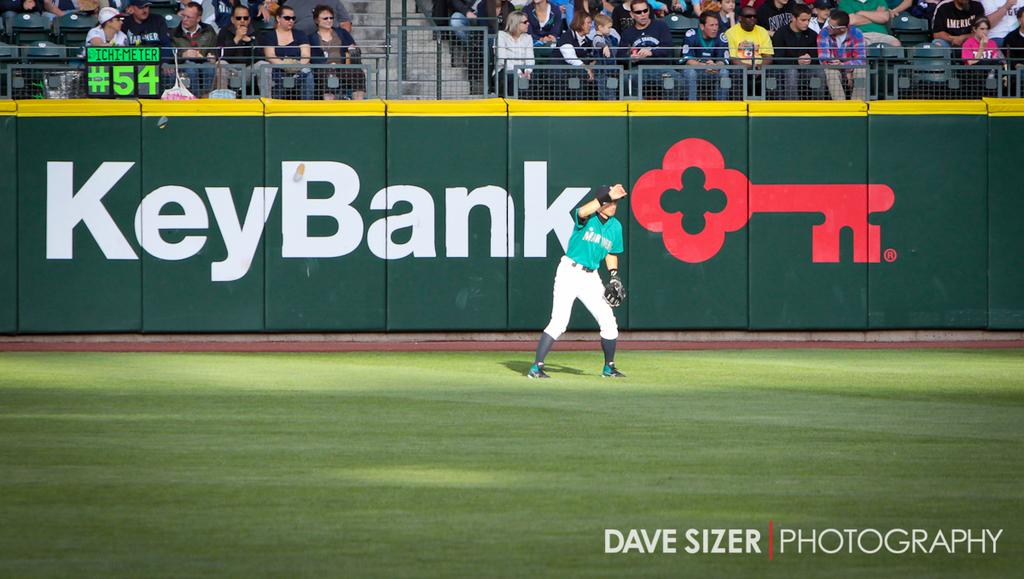Provide a one-sentence caption for the provided image. A baseball stadium is sponsored by Key Bank during a game. 